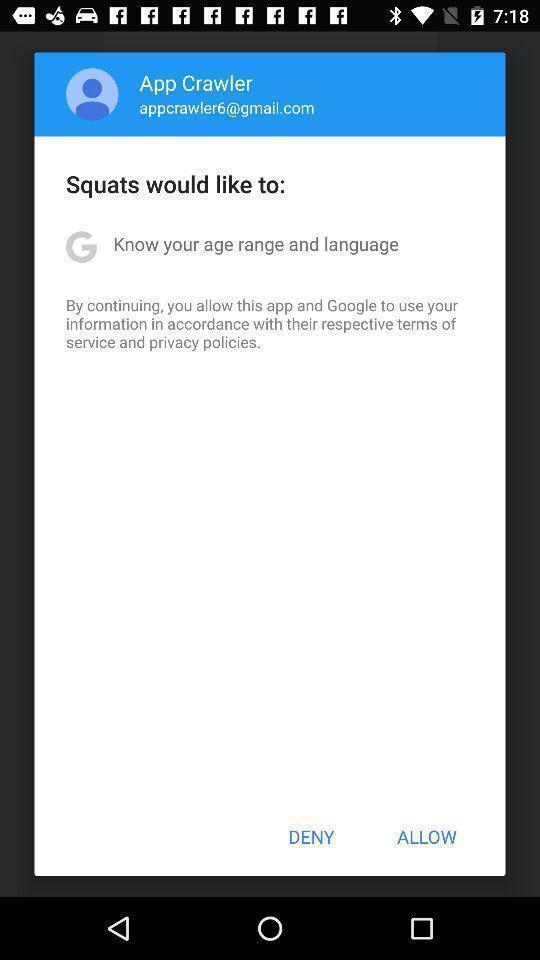What can you discern from this picture? Popup showing of allow and deny option. 